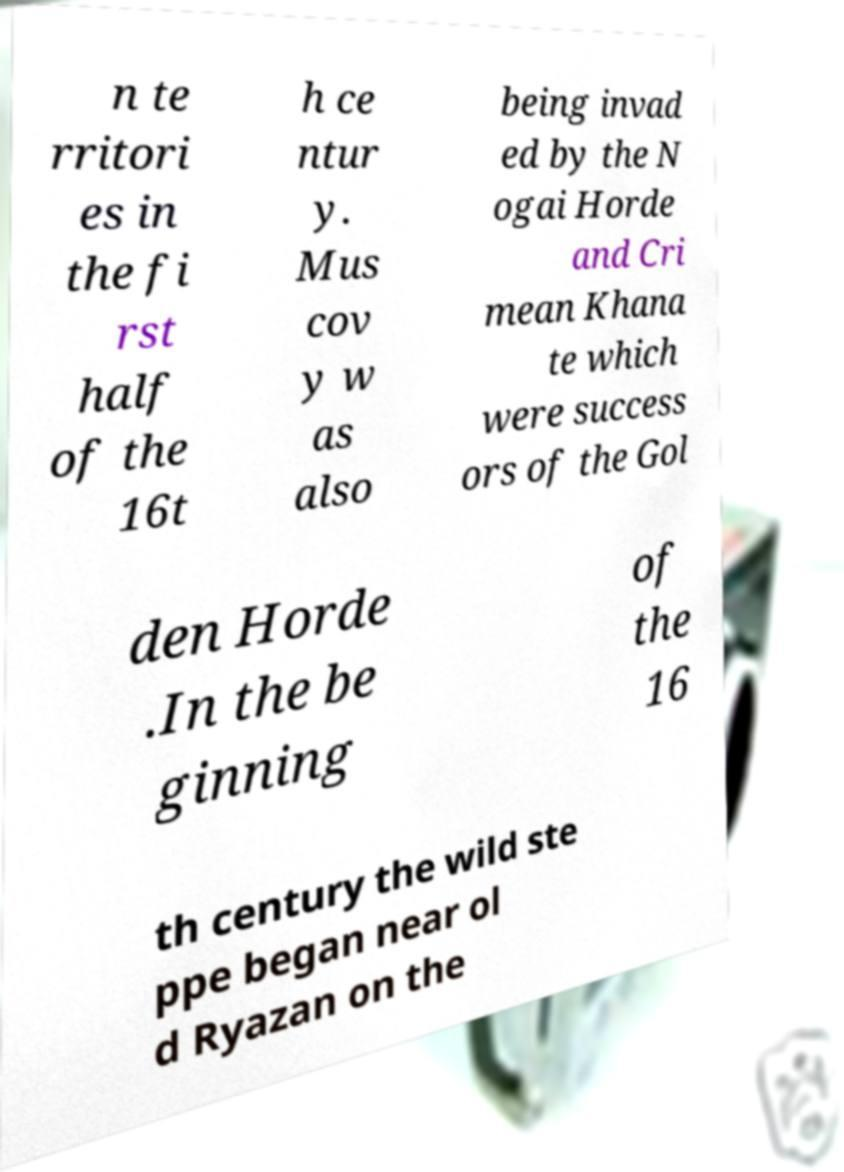Can you read and provide the text displayed in the image?This photo seems to have some interesting text. Can you extract and type it out for me? n te rritori es in the fi rst half of the 16t h ce ntur y. Mus cov y w as also being invad ed by the N ogai Horde and Cri mean Khana te which were success ors of the Gol den Horde .In the be ginning of the 16 th century the wild ste ppe began near ol d Ryazan on the 